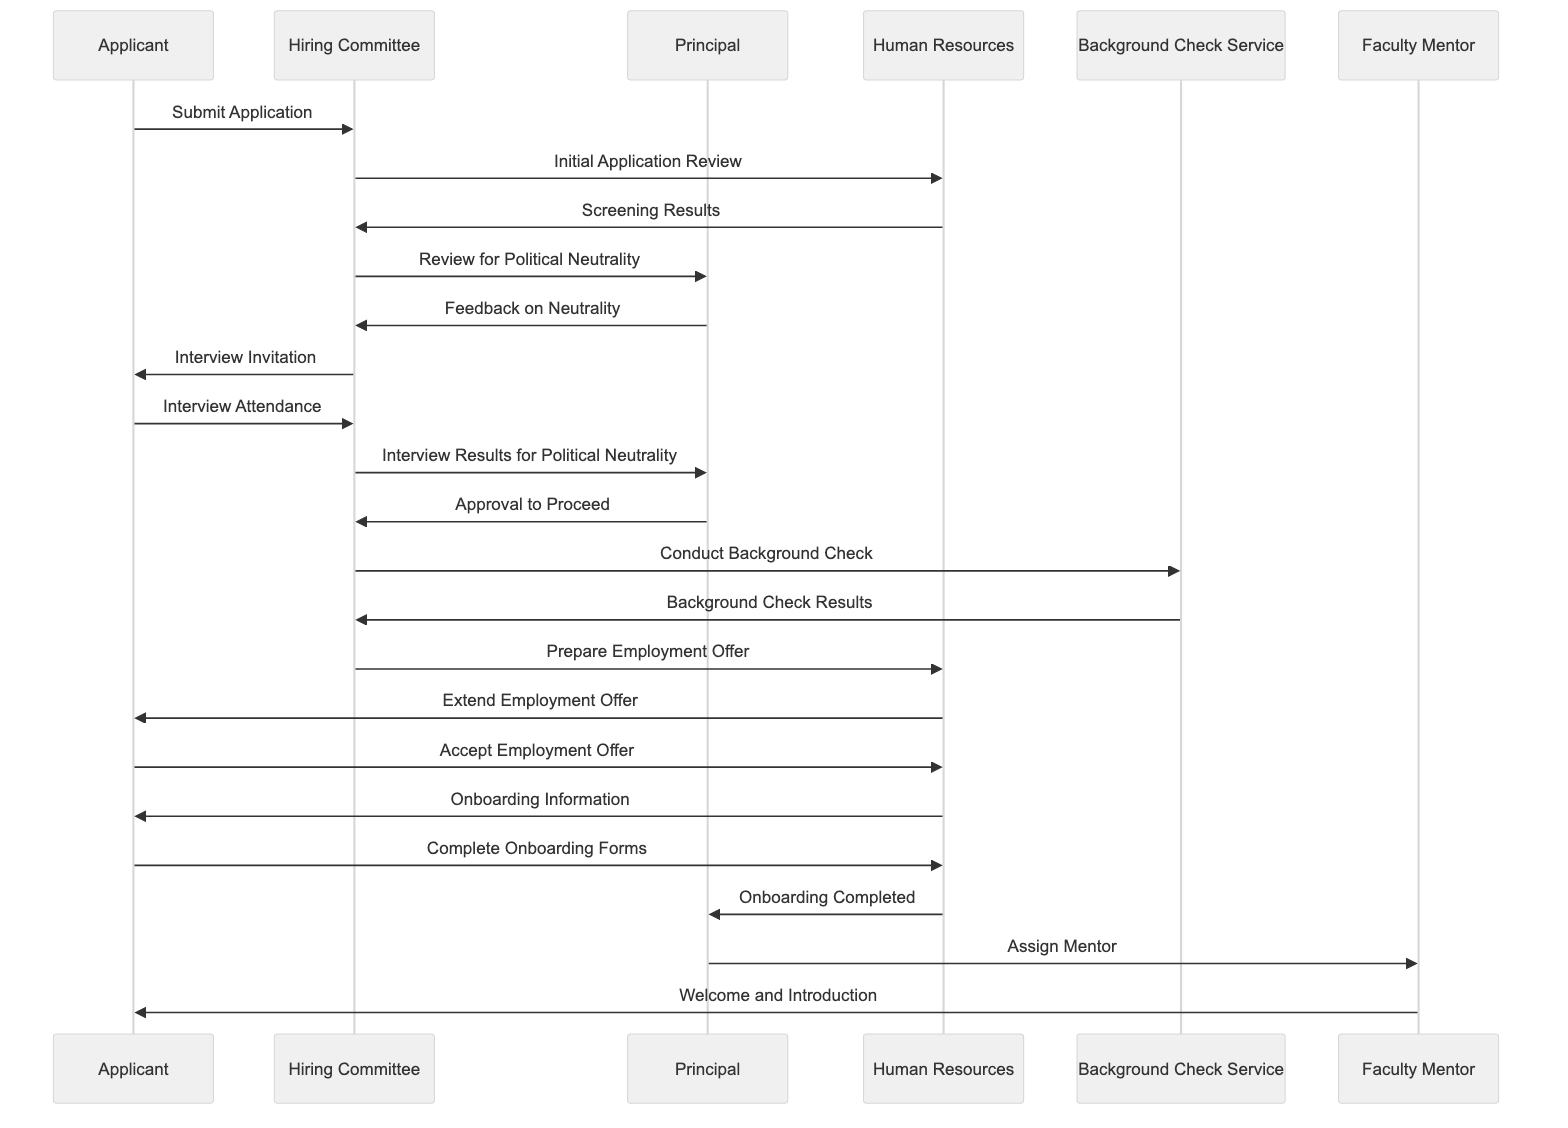What is the first message sent in the diagram? The diagram shows the first interaction is between the Applicant and the Hiring Committee where the message "Submit Application" is sent from the Applicant to the Hiring Committee.
Answer: Submit Application How many participants are involved in the hiring process? The diagram includes six participants: Applicant, Hiring Committee, Principal, Human Resources, Background Check Service, and Faculty Mentor.
Answer: Six Who provides feedback on political neutrality? The feedback on political neutrality is provided by the Principal to the Hiring Committee after they review the application.
Answer: Principal What is the last step in the onboarding process? The last step in the onboarding process is the Faculty Mentor welcoming and introducing the Applicant. This occurs after the Principal assigns the Faculty Mentor.
Answer: Welcome and Introduction Which participant extends the employment offer? The Human Resources participant is responsible for extending the employment offer to the Applicant based on the preparation by the Hiring Committee.
Answer: Human Resources What message does the Hiring Committee send after conducting an interview? After conducting the interview, the Hiring Committee sends the message "Interview Results for Political Neutrality" to the Principal.
Answer: Interview Results for Political Neutrality Which service conducts the background check? The background check is conducted by the Background Check Service as indicated by the message "Conduct Background Check" from the Hiring Committee.
Answer: Background Check Service What stage does the Applicant reach after they accept the employment offer? After accepting the employment offer, the Applicant receives onboarding information from Human Resources, marking their transition into the onboarding stage.
Answer: Onboarding Information How does the Principal ensure political neutrality in the process? The Principal ensures political neutrality by reviewing the applications and providing feedback on neutrality to the Hiring Committee.
Answer: Review for Political Neutrality 